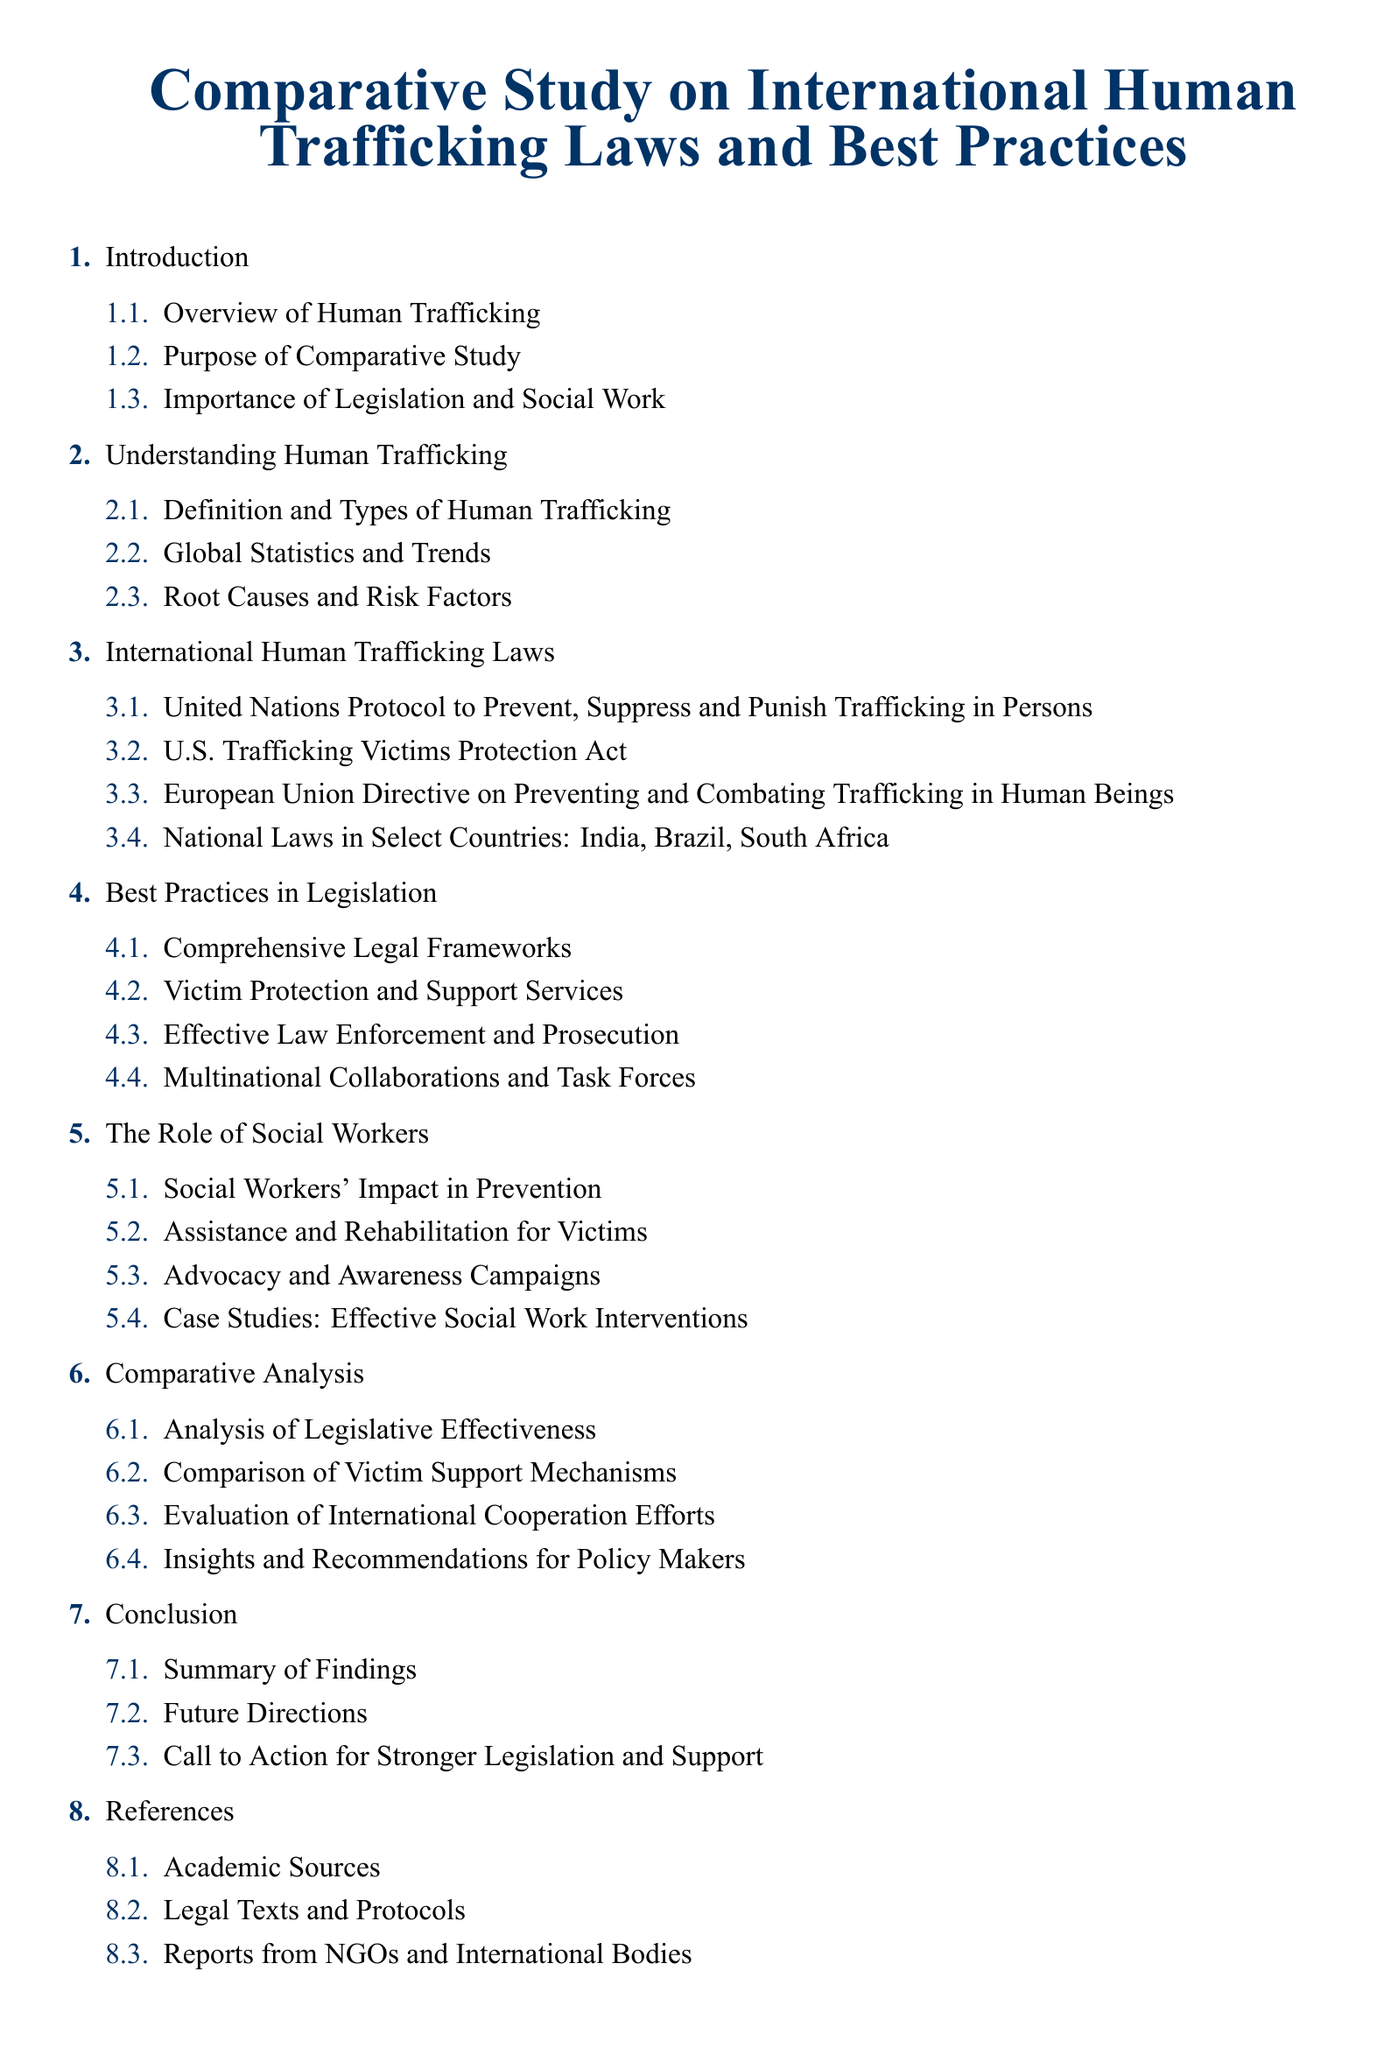What is the title of the document? The title is presented at the beginning of the document.
Answer: Comparative Study on International Human Trafficking Laws and Best Practices How many sections are in the document? The document consists of eight main sections listed in the table of contents.
Answer: 8 What is the first subsection under 'Understanding Human Trafficking'? The subsections provide detailed breakdowns under their respective main sections.
Answer: Definition and Types of Human Trafficking Which country's national laws are specifically mentioned? The list in the 'International Human Trafficking Laws' section includes specific countries.
Answer: India, Brazil, South Africa What do the best practices in legislation focus on? The document outlines certain focus areas within the best practices section.
Answer: Comprehensive Legal Frameworks What is one role of social workers mentioned in the document? The 'Role of Social Workers' section outlines various capacities in which they operate.
Answer: Assistance and Rehabilitation for Victims What type of analysis is provided in the document? The document includes a section dedicated to analyzing aspects of the legislative framework.
Answer: Comparative Analysis What is a key recommendation for policymakers? The conclusion summarizes findings and suggests actionable steps for improvement.
Answer: Call to Action for Stronger Legislation and Support 